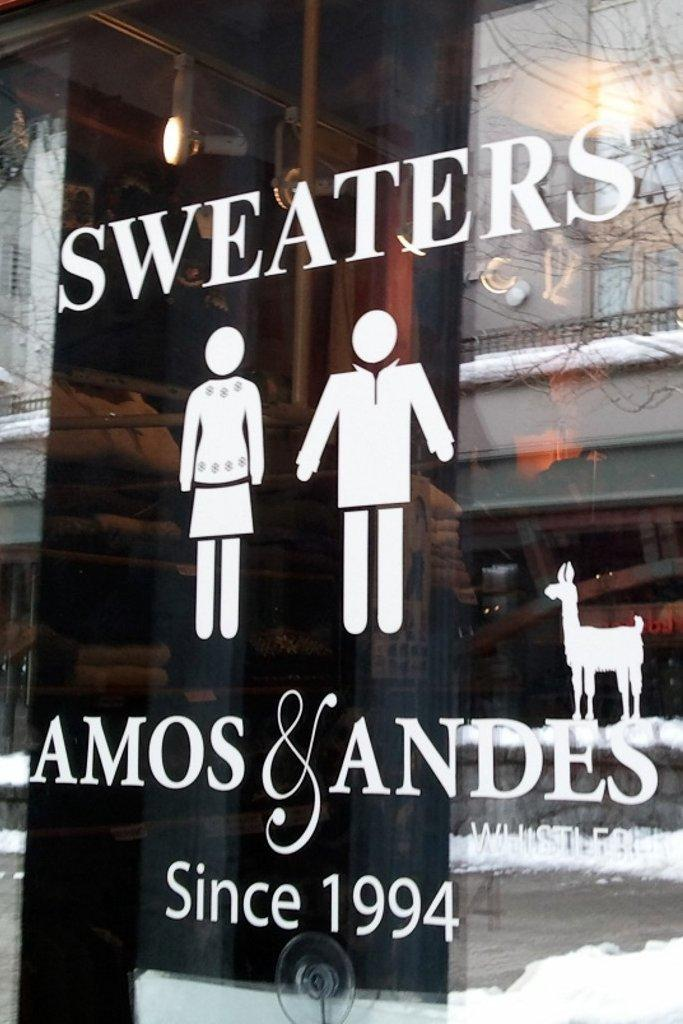What is located in the foreground of the picture? There is a glass in the foreground of the picture. What is on the glass? There are person stickers and an antelope sticker on the glass, as well as text. What can be seen in the background of the picture? There is light and other wooden objects in the background of the picture. How many fingers are visible on the person stickers in the image? There is no indication of fingers on the person stickers in the image, as they are simply stickers on a glass. 